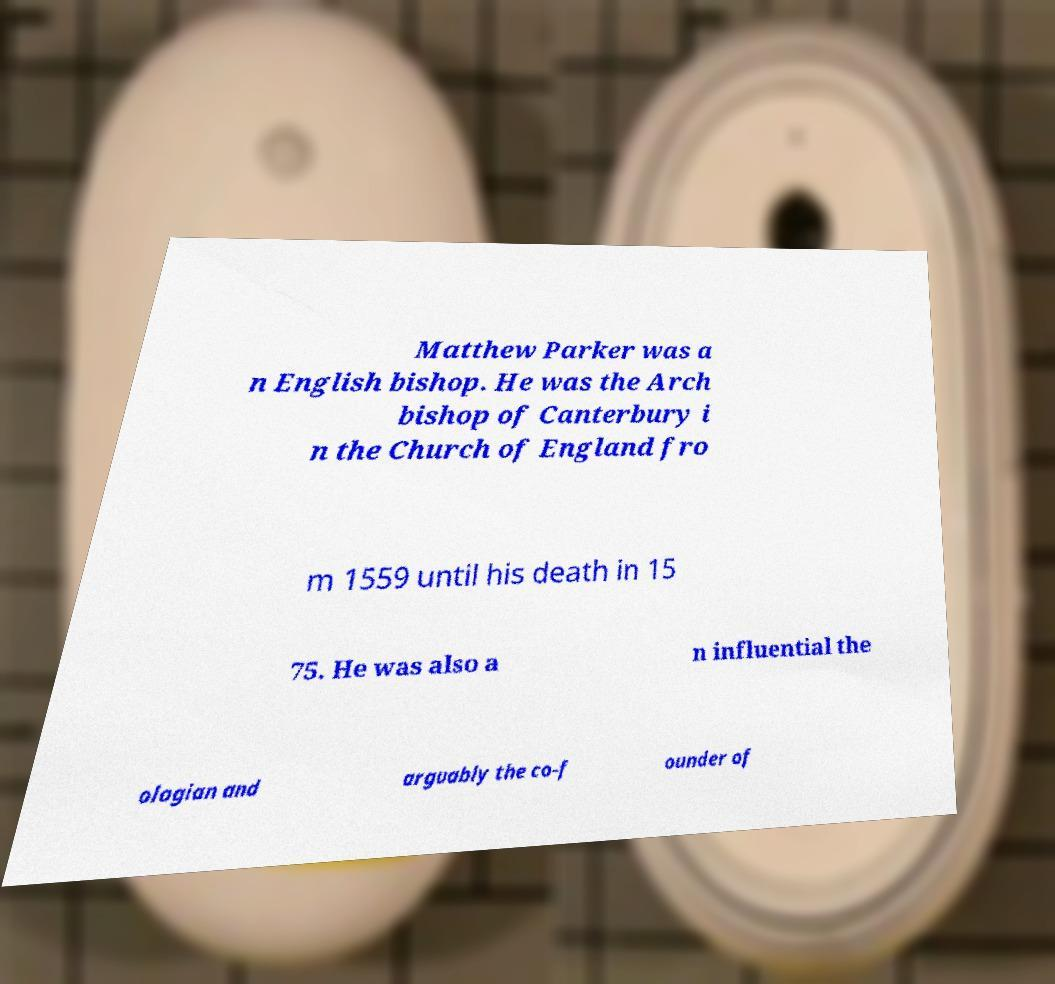Please read and relay the text visible in this image. What does it say? Matthew Parker was a n English bishop. He was the Arch bishop of Canterbury i n the Church of England fro m 1559 until his death in 15 75. He was also a n influential the ologian and arguably the co-f ounder of 